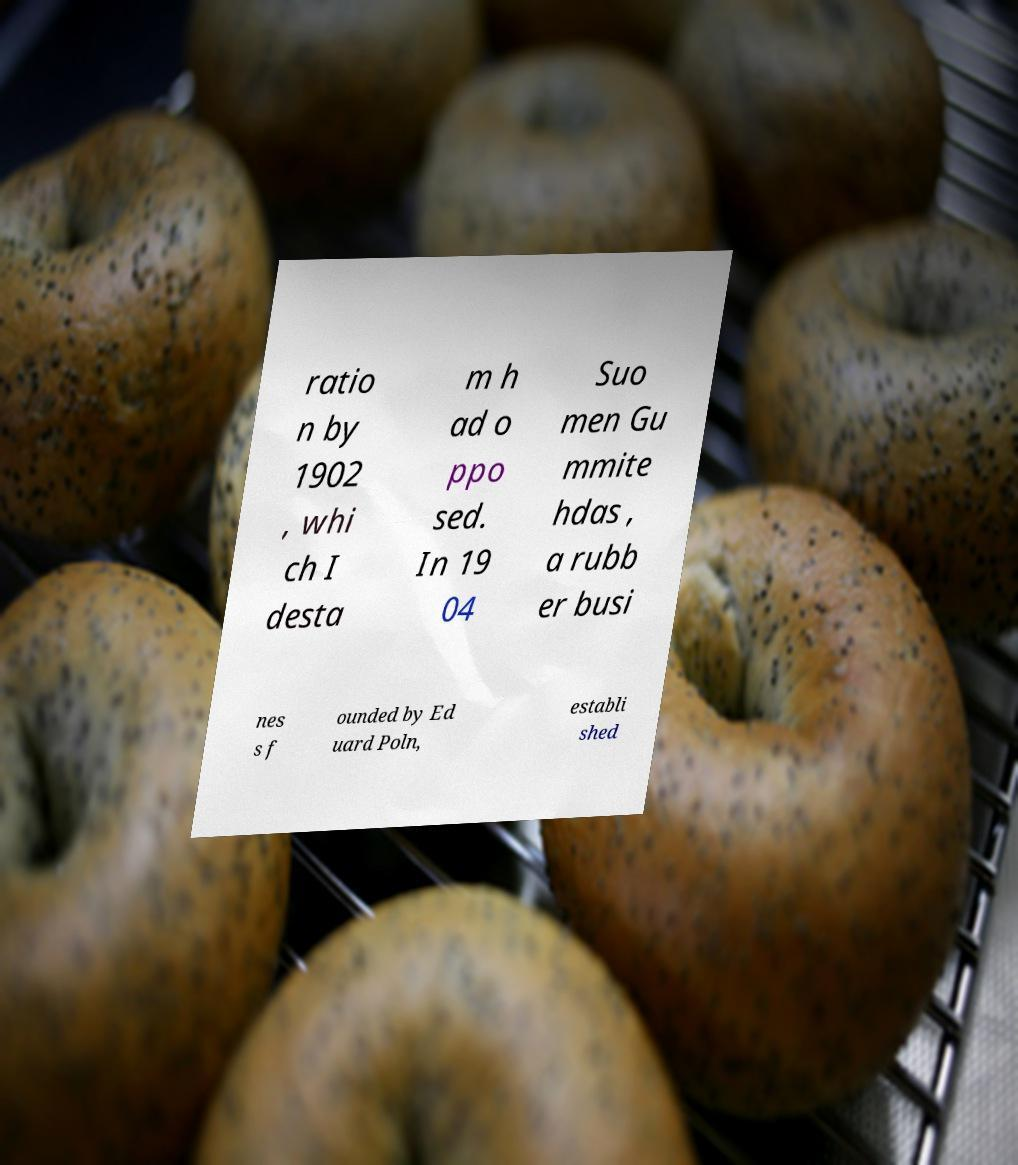Could you assist in decoding the text presented in this image and type it out clearly? ratio n by 1902 , whi ch I desta m h ad o ppo sed. In 19 04 Suo men Gu mmite hdas , a rubb er busi nes s f ounded by Ed uard Poln, establi shed 